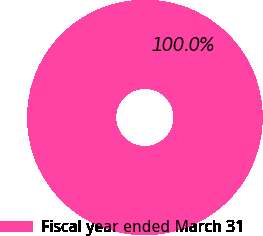Convert chart. <chart><loc_0><loc_0><loc_500><loc_500><pie_chart><fcel>Fiscal year ended March 31<nl><fcel>100.0%<nl></chart> 